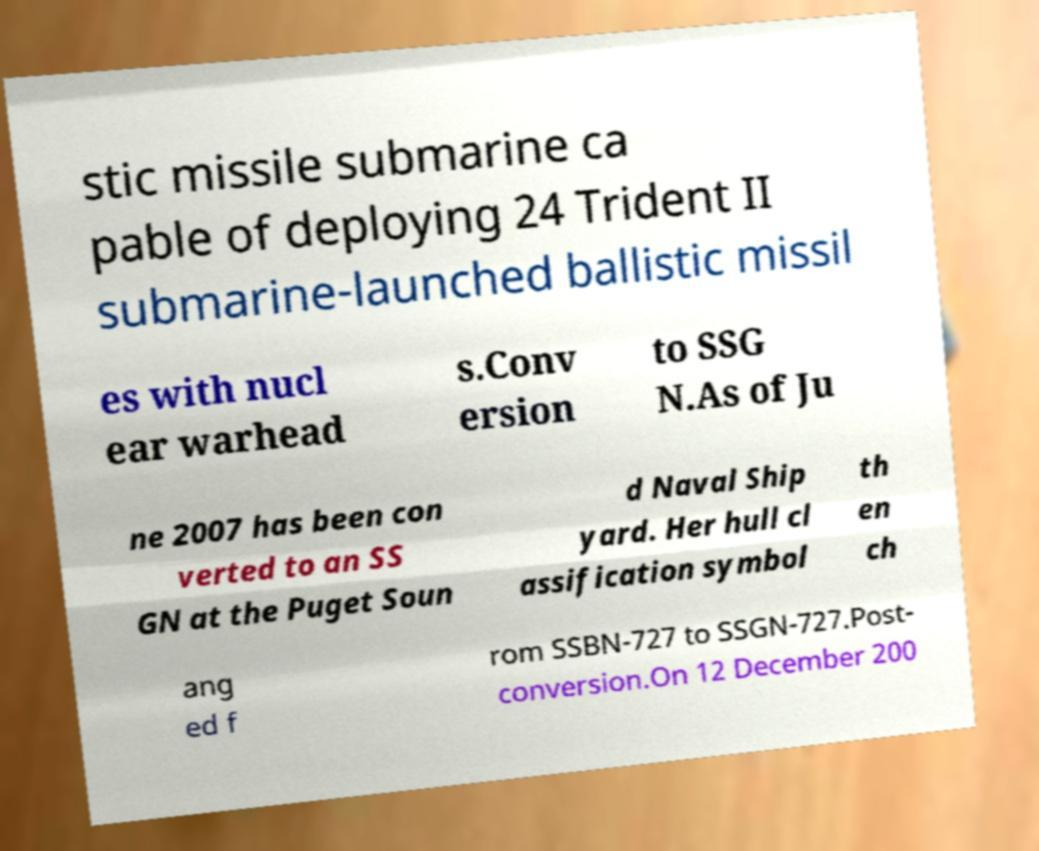Can you read and provide the text displayed in the image?This photo seems to have some interesting text. Can you extract and type it out for me? stic missile submarine ca pable of deploying 24 Trident II submarine-launched ballistic missil es with nucl ear warhead s.Conv ersion to SSG N.As of Ju ne 2007 has been con verted to an SS GN at the Puget Soun d Naval Ship yard. Her hull cl assification symbol th en ch ang ed f rom SSBN-727 to SSGN-727.Post- conversion.On 12 December 200 